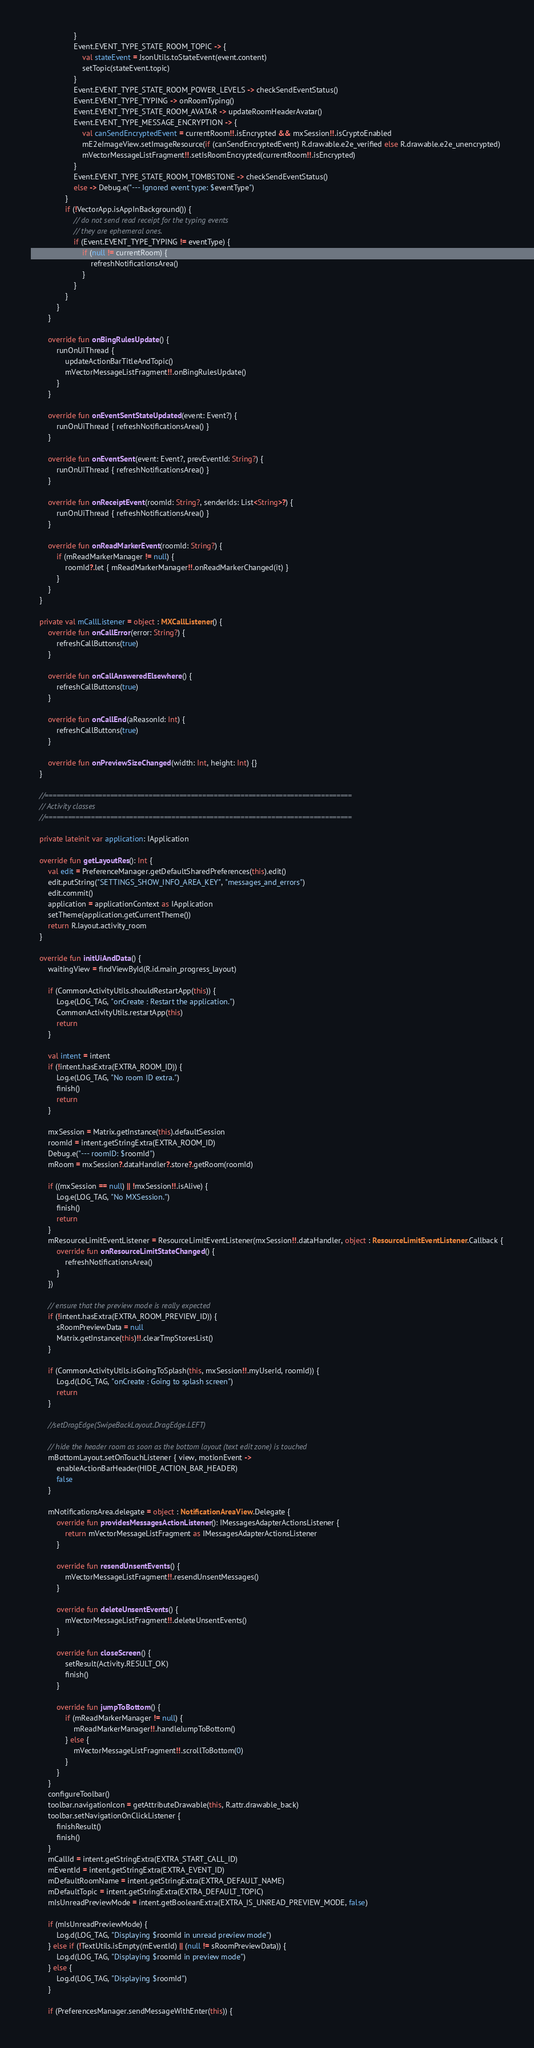Convert code to text. <code><loc_0><loc_0><loc_500><loc_500><_Kotlin_>                    }
                    Event.EVENT_TYPE_STATE_ROOM_TOPIC -> {
                        val stateEvent = JsonUtils.toStateEvent(event.content)
                        setTopic(stateEvent.topic)
                    }
                    Event.EVENT_TYPE_STATE_ROOM_POWER_LEVELS -> checkSendEventStatus()
                    Event.EVENT_TYPE_TYPING -> onRoomTyping()
                    Event.EVENT_TYPE_STATE_ROOM_AVATAR -> updateRoomHeaderAvatar()
                    Event.EVENT_TYPE_MESSAGE_ENCRYPTION -> {
                        val canSendEncryptedEvent = currentRoom!!.isEncrypted && mxSession!!.isCryptoEnabled
                        mE2eImageView.setImageResource(if (canSendEncryptedEvent) R.drawable.e2e_verified else R.drawable.e2e_unencrypted)
                        mVectorMessageListFragment!!.setIsRoomEncrypted(currentRoom!!.isEncrypted)
                    }
                    Event.EVENT_TYPE_STATE_ROOM_TOMBSTONE -> checkSendEventStatus()
                    else -> Debug.e("--- Ignored event type: $eventType")
                }
                if (!VectorApp.isAppInBackground()) {
                    // do not send read receipt for the typing events
                    // they are ephemeral ones.
                    if (Event.EVENT_TYPE_TYPING != eventType) {
                        if (null != currentRoom) {
                            refreshNotificationsArea()
                        }
                    }
                }
            }
        }

        override fun onBingRulesUpdate() {
            runOnUiThread {
                updateActionBarTitleAndTopic()
                mVectorMessageListFragment!!.onBingRulesUpdate()
            }
        }

        override fun onEventSentStateUpdated(event: Event?) {
            runOnUiThread { refreshNotificationsArea() }
        }

        override fun onEventSent(event: Event?, prevEventId: String?) {
            runOnUiThread { refreshNotificationsArea() }
        }

        override fun onReceiptEvent(roomId: String?, senderIds: List<String>?) {
            runOnUiThread { refreshNotificationsArea() }
        }

        override fun onReadMarkerEvent(roomId: String?) {
            if (mReadMarkerManager != null) {
                roomId?.let { mReadMarkerManager!!.onReadMarkerChanged(it) }
            }
        }
    }

    private val mCallListener = object : MXCallListener() {
        override fun onCallError(error: String?) {
            refreshCallButtons(true)
        }

        override fun onCallAnsweredElsewhere() {
            refreshCallButtons(true)
        }

        override fun onCallEnd(aReasonId: Int) {
            refreshCallButtons(true)
        }

        override fun onPreviewSizeChanged(width: Int, height: Int) {}
    }

    //================================================================================
    // Activity classes
    //================================================================================

    private lateinit var application: IApplication

    override fun getLayoutRes(): Int {
        val edit = PreferenceManager.getDefaultSharedPreferences(this).edit()
        edit.putString("SETTINGS_SHOW_INFO_AREA_KEY", "messages_and_errors")
        edit.commit()
        application = applicationContext as IApplication
        setTheme(application.getCurrentTheme())
        return R.layout.activity_room
    }

    override fun initUiAndData() {
        waitingView = findViewById(R.id.main_progress_layout)

        if (CommonActivityUtils.shouldRestartApp(this)) {
            Log.e(LOG_TAG, "onCreate : Restart the application.")
            CommonActivityUtils.restartApp(this)
            return
        }

        val intent = intent
        if (!intent.hasExtra(EXTRA_ROOM_ID)) {
            Log.e(LOG_TAG, "No room ID extra.")
            finish()
            return
        }

        mxSession = Matrix.getInstance(this).defaultSession
        roomId = intent.getStringExtra(EXTRA_ROOM_ID)
        Debug.e("--- roomID: $roomId")
        mRoom = mxSession?.dataHandler?.store?.getRoom(roomId)

        if ((mxSession == null) || !mxSession!!.isAlive) {
            Log.e(LOG_TAG, "No MXSession.")
            finish()
            return
        }
        mResourceLimitEventListener = ResourceLimitEventListener(mxSession!!.dataHandler, object : ResourceLimitEventListener.Callback {
            override fun onResourceLimitStateChanged() {
                refreshNotificationsArea()
            }
        })

        // ensure that the preview mode is really expected
        if (!intent.hasExtra(EXTRA_ROOM_PREVIEW_ID)) {
            sRoomPreviewData = null
            Matrix.getInstance(this)!!.clearTmpStoresList()
        }

        if (CommonActivityUtils.isGoingToSplash(this, mxSession!!.myUserId, roomId)) {
            Log.d(LOG_TAG, "onCreate : Going to splash screen")
            return
        }

        //setDragEdge(SwipeBackLayout.DragEdge.LEFT)

        // hide the header room as soon as the bottom layout (text edit zone) is touched
        mBottomLayout.setOnTouchListener { view, motionEvent ->
            enableActionBarHeader(HIDE_ACTION_BAR_HEADER)
            false
        }

        mNotificationsArea.delegate = object : NotificationAreaView.Delegate {
            override fun providesMessagesActionListener(): IMessagesAdapterActionsListener {
                return mVectorMessageListFragment as IMessagesAdapterActionsListener
            }

            override fun resendUnsentEvents() {
                mVectorMessageListFragment!!.resendUnsentMessages()
            }

            override fun deleteUnsentEvents() {
                mVectorMessageListFragment!!.deleteUnsentEvents()
            }

            override fun closeScreen() {
                setResult(Activity.RESULT_OK)
                finish()
            }

            override fun jumpToBottom() {
                if (mReadMarkerManager != null) {
                    mReadMarkerManager!!.handleJumpToBottom()
                } else {
                    mVectorMessageListFragment!!.scrollToBottom(0)
                }
            }
        }
        configureToolbar()
        toolbar.navigationIcon = getAttributeDrawable(this, R.attr.drawable_back)
        toolbar.setNavigationOnClickListener {
            finishResult()
            finish()
        }
        mCallId = intent.getStringExtra(EXTRA_START_CALL_ID)
        mEventId = intent.getStringExtra(EXTRA_EVENT_ID)
        mDefaultRoomName = intent.getStringExtra(EXTRA_DEFAULT_NAME)
        mDefaultTopic = intent.getStringExtra(EXTRA_DEFAULT_TOPIC)
        mIsUnreadPreviewMode = intent.getBooleanExtra(EXTRA_IS_UNREAD_PREVIEW_MODE, false)

        if (mIsUnreadPreviewMode) {
            Log.d(LOG_TAG, "Displaying $roomId in unread preview mode")
        } else if (!TextUtils.isEmpty(mEventId) || (null != sRoomPreviewData)) {
            Log.d(LOG_TAG, "Displaying $roomId in preview mode")
        } else {
            Log.d(LOG_TAG, "Displaying $roomId")
        }

        if (PreferencesManager.sendMessageWithEnter(this)) {</code> 